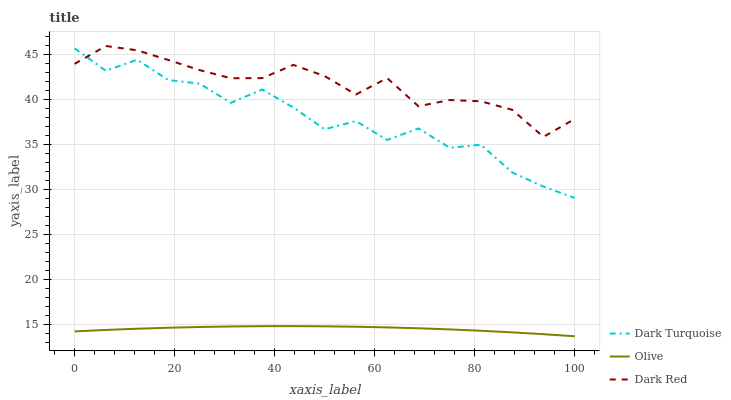Does Olive have the minimum area under the curve?
Answer yes or no. Yes. Does Dark Red have the maximum area under the curve?
Answer yes or no. Yes. Does Dark Turquoise have the minimum area under the curve?
Answer yes or no. No. Does Dark Turquoise have the maximum area under the curve?
Answer yes or no. No. Is Olive the smoothest?
Answer yes or no. Yes. Is Dark Turquoise the roughest?
Answer yes or no. Yes. Is Dark Red the smoothest?
Answer yes or no. No. Is Dark Red the roughest?
Answer yes or no. No. Does Olive have the lowest value?
Answer yes or no. Yes. Does Dark Turquoise have the lowest value?
Answer yes or no. No. Does Dark Red have the highest value?
Answer yes or no. Yes. Does Dark Turquoise have the highest value?
Answer yes or no. No. Is Olive less than Dark Turquoise?
Answer yes or no. Yes. Is Dark Turquoise greater than Olive?
Answer yes or no. Yes. Does Dark Red intersect Dark Turquoise?
Answer yes or no. Yes. Is Dark Red less than Dark Turquoise?
Answer yes or no. No. Is Dark Red greater than Dark Turquoise?
Answer yes or no. No. Does Olive intersect Dark Turquoise?
Answer yes or no. No. 